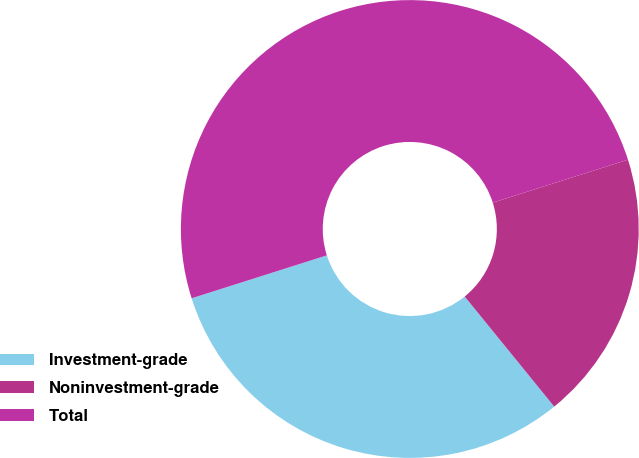<chart> <loc_0><loc_0><loc_500><loc_500><pie_chart><fcel>Investment-grade<fcel>Noninvestment-grade<fcel>Total<nl><fcel>30.97%<fcel>19.03%<fcel>50.0%<nl></chart> 